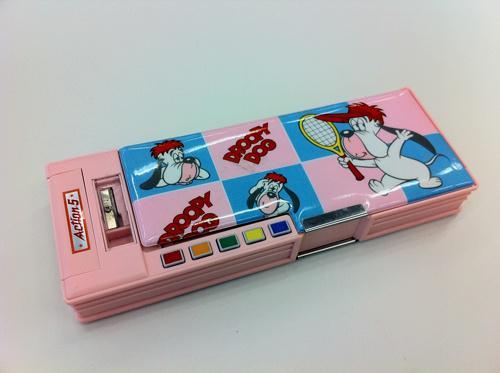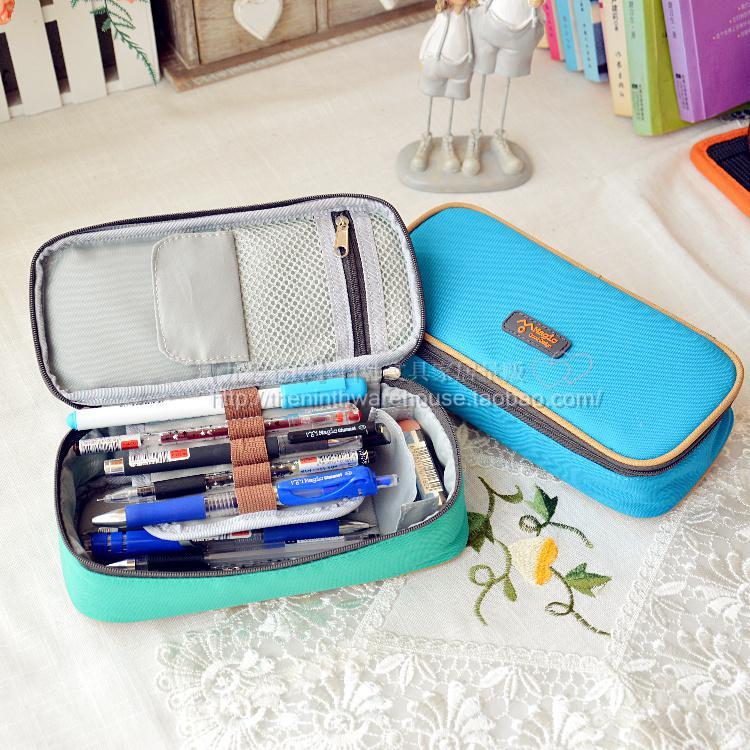The first image is the image on the left, the second image is the image on the right. Considering the images on both sides, is "There is one pink case in the image on the left." valid? Answer yes or no. Yes. 